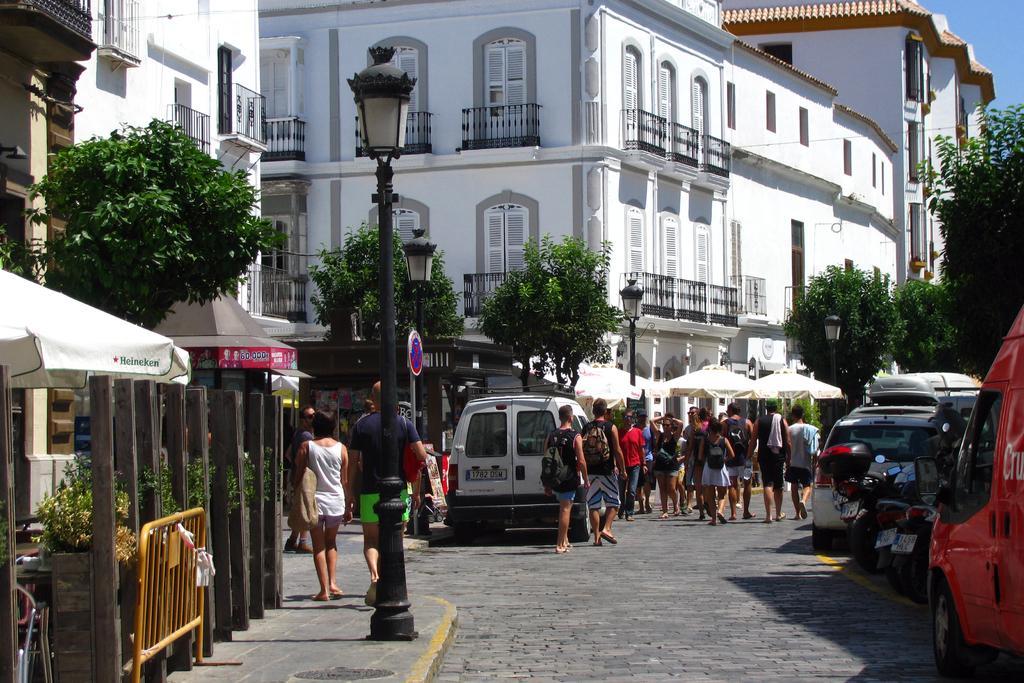Please provide a concise description of this image. In this image, we can see so many buildings, poles, lights, trees, railings, walls and windows. At the bottom of the image, we can see few vehicles, people, barricade, plants and poles. Here we can see an umbrella, sign board. In this image, we can see few people are walking. In the background we can see few umbrellas. 